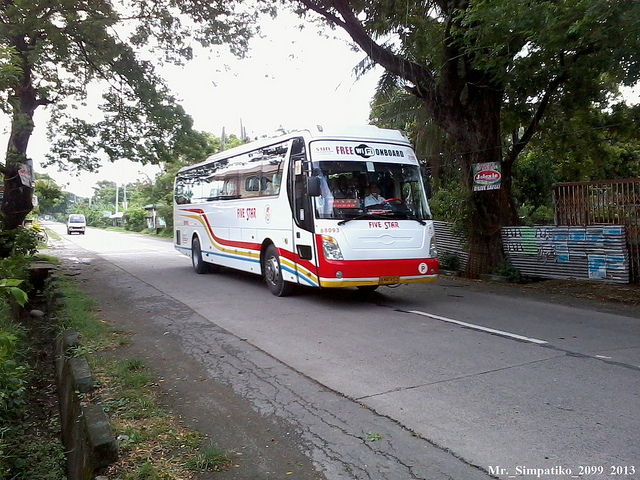Please extract the text content from this image. Mr. FREE ONBOARD FIVE Simpatiko 2013 2099 